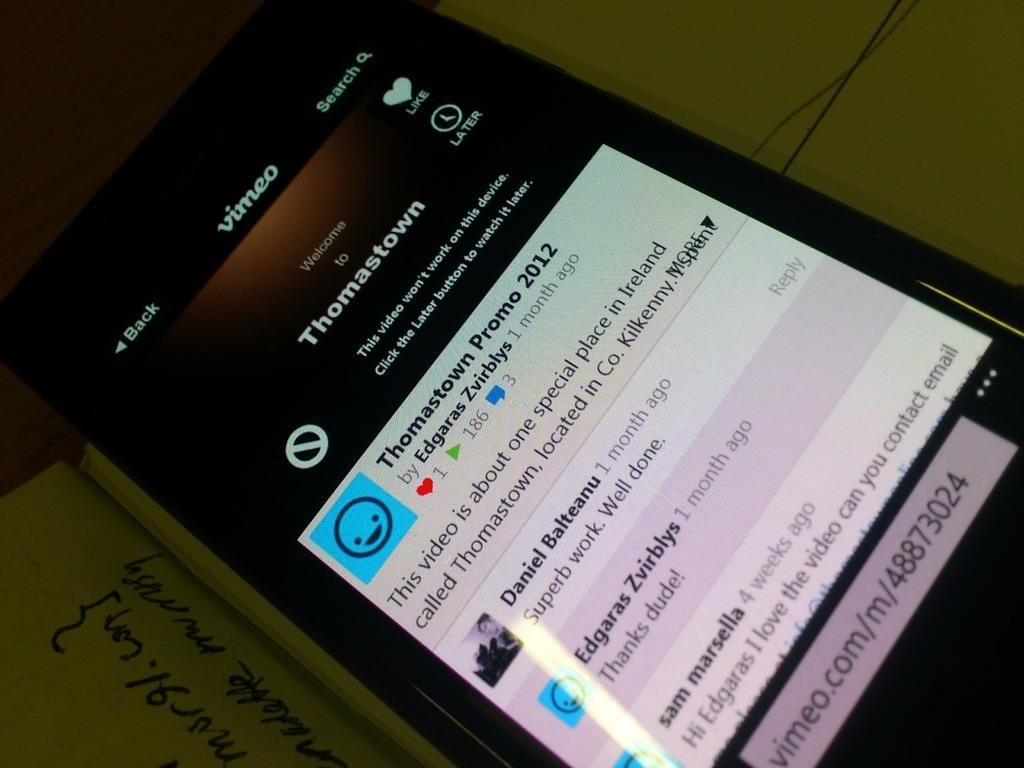Provide a one-sentence caption for the provided image. On a cellphone screen, Thomastown information appears with a video link. 